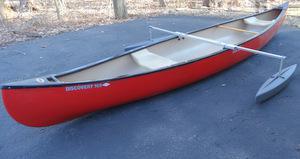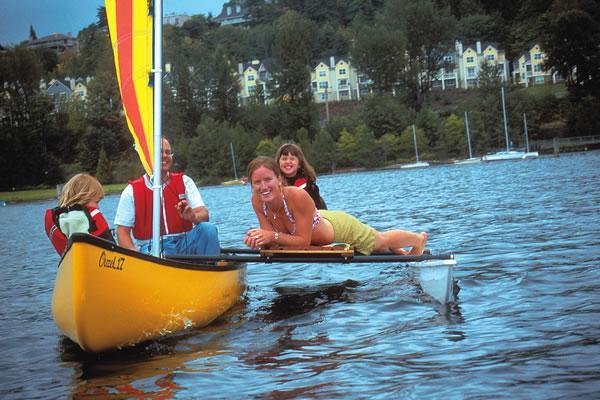The first image is the image on the left, the second image is the image on the right. Analyze the images presented: Is the assertion "At least one person is in a boat floating on water." valid? Answer yes or no. Yes. The first image is the image on the left, the second image is the image on the right. Considering the images on both sides, is "An image shows at least one person in a yellow canoe on the water." valid? Answer yes or no. Yes. 